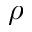Convert formula to latex. <formula><loc_0><loc_0><loc_500><loc_500>\rho</formula> 